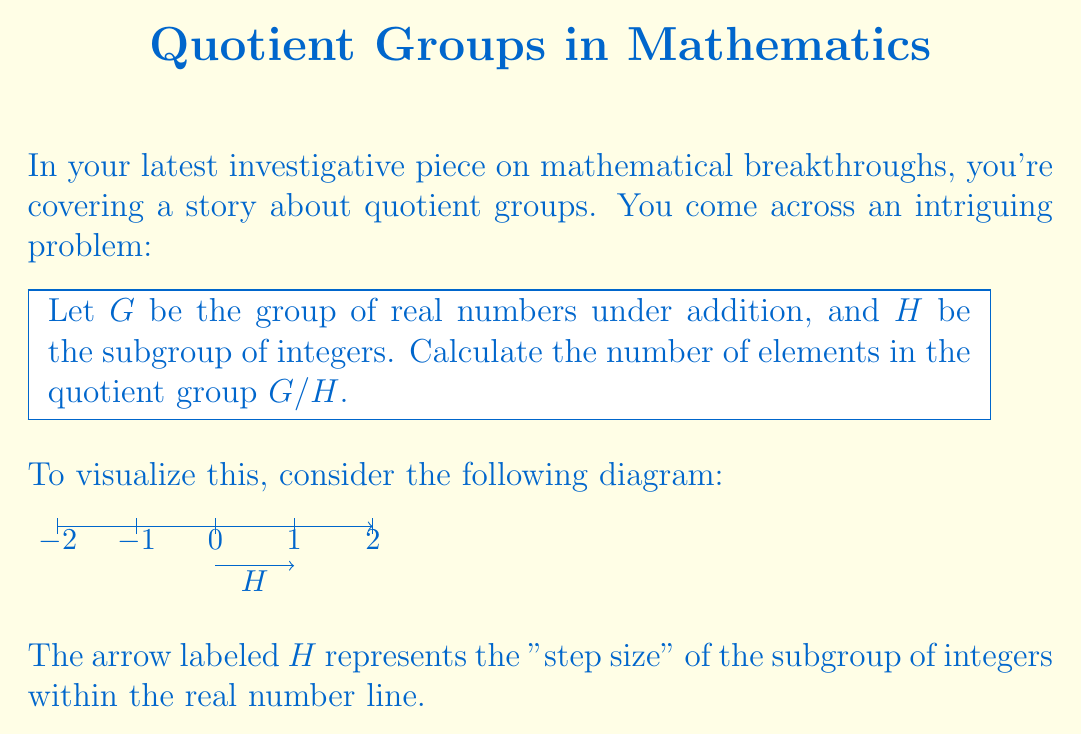Can you answer this question? To solve this problem, we need to understand the concept of quotient groups and cosets:

1) The quotient group $G/H$ consists of all cosets of $H$ in $G$.

2) Each coset is of the form $g + H = \{g + h : h \in H\}$ for some $g \in G$.

3) In this case, $G = (\mathbb{R}, +)$ and $H = (\mathbb{Z}, +)$.

4) The cosets of $H$ in $G$ are of the form $r + \mathbb{Z}$, where $r \in \mathbb{R}$.

5) Two cosets $r_1 + \mathbb{Z}$ and $r_2 + \mathbb{Z}$ are equal if and only if $r_1 - r_2 \in \mathbb{Z}$.

6) This means that each coset can be uniquely represented by a real number in the interval $[0, 1)$.

7) Therefore, there is a one-to-one correspondence between the cosets in $G/H$ and the real numbers in $[0, 1)$.

8) The set of real numbers in $[0, 1)$ is uncountably infinite.

Thus, the quotient group $G/H$ has uncountably infinitely many elements.
Answer: Uncountably infinite 